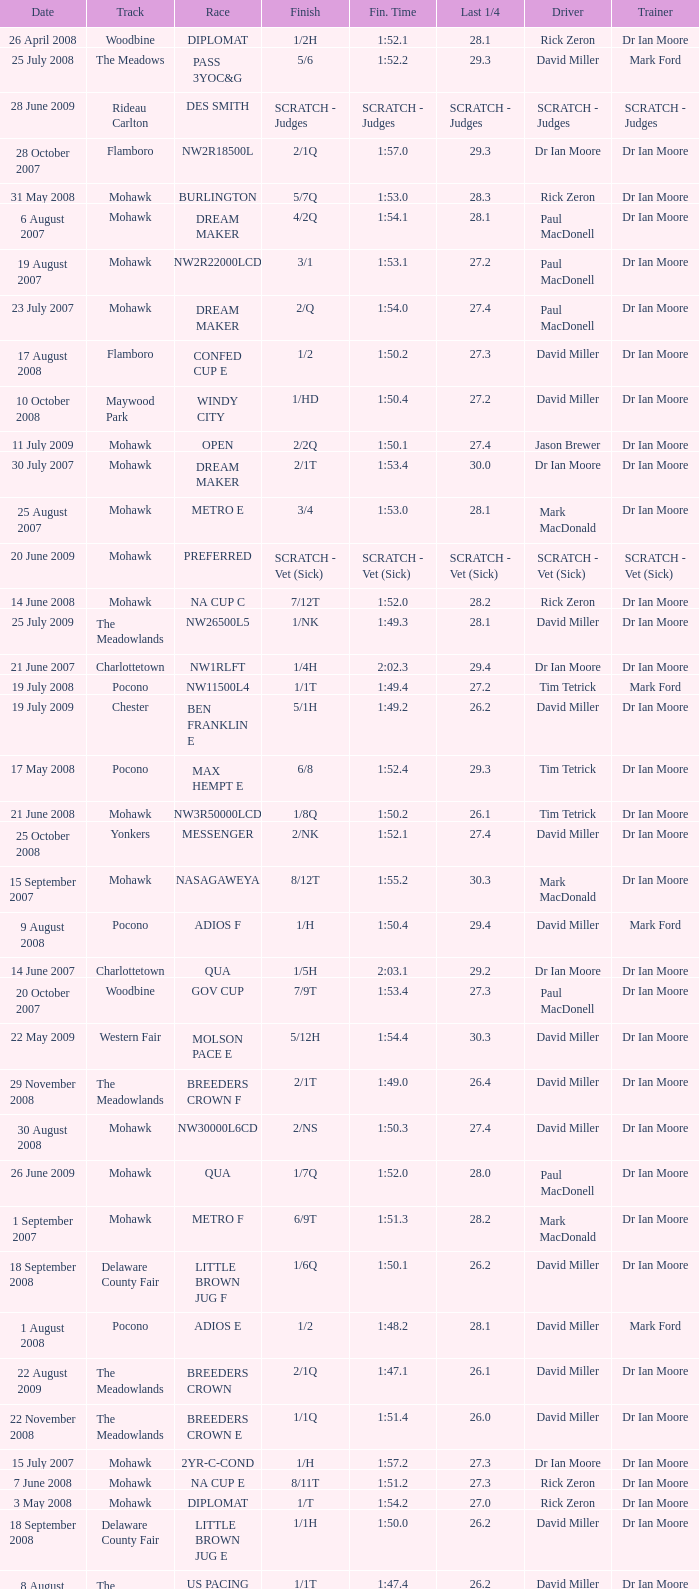What is the finishing time with a 2/1q finish on the Meadowlands track? 1:47.1. 